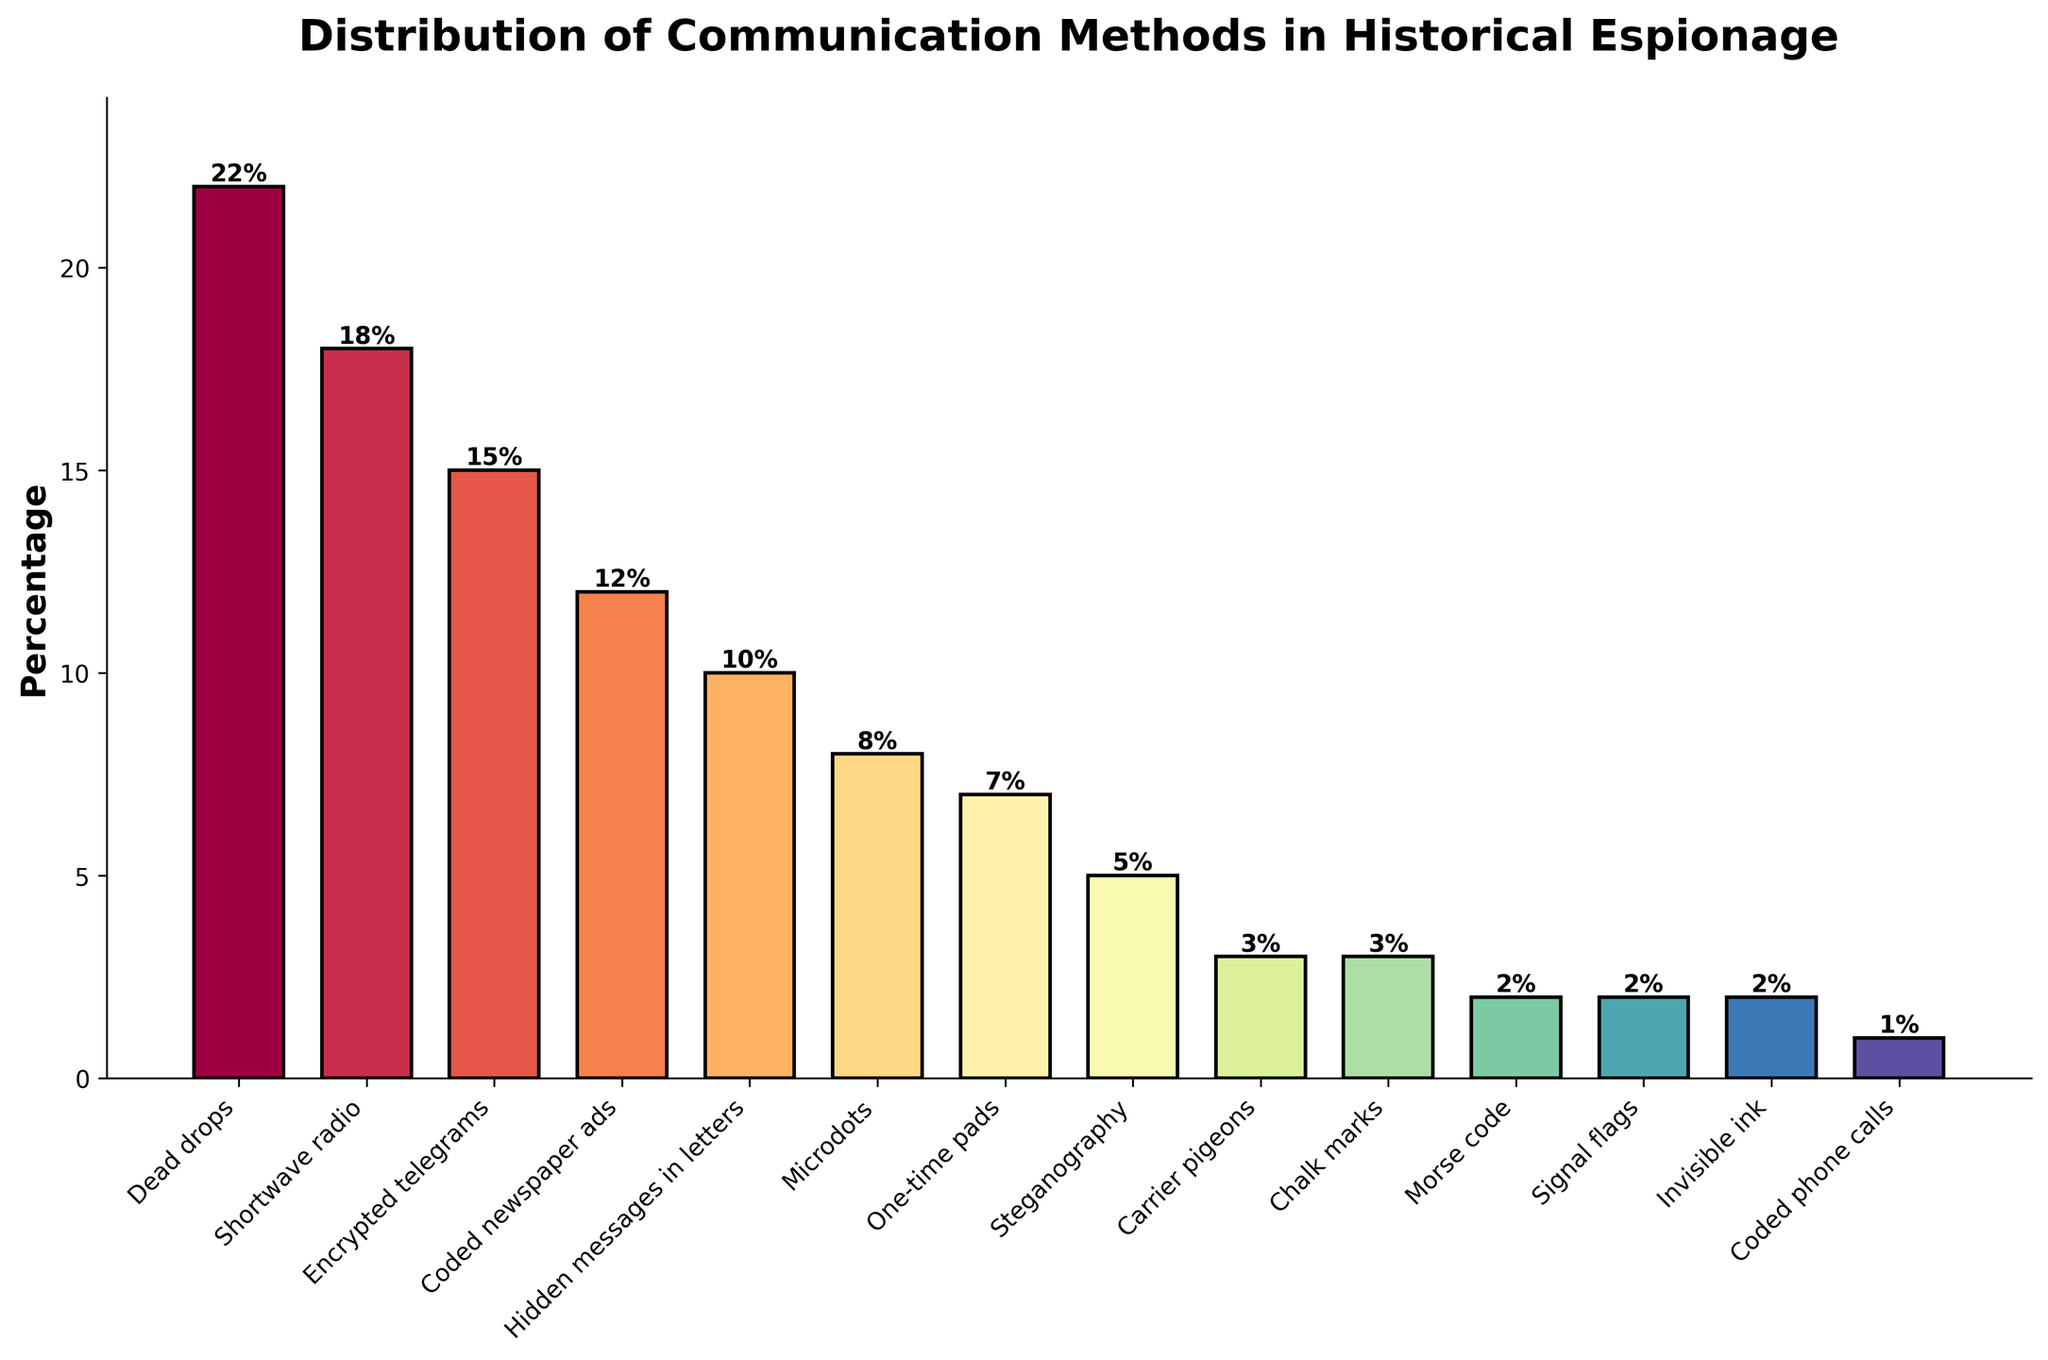What is the method with the highest percentage? The bar chart shows that the method with the highest percentage is at the top of the y-axis, which is "Dead drops" at 22%.
Answer: Dead drops What is the total percentage of methods with a percentage of 10% or higher? Summing the percentages of methods with 10% or higher: Dead drops (22%) + Shortwave radio (18%) + Encrypted telegrams (15%) + Coded newspaper ads (12%) + Hidden messages in letters (10%) = 77%
Answer: 77% Which methods have equal percentages, and what are they? Checking the bar heights for methods with the same percentage, both "Carrier pigeons" and "Chalk marks" have a percentage of 3%, as do "Morse code", "Signal flags", and "Invisible ink" with 2%.
Answer: Carrier pigeons and Chalk marks; Morse code, Signal flags, and Invisible ink What is the difference in percentage between the methods with the highest and the lowest usage? Subtract the percentage of the lowest method (Coded phone calls at 1%) from the highest method (Dead drops at 22%): 22% - 1% = 21%
Answer: 21% How many communication methods are represented in the plot? Count the number of distinct bars (methods) on the x-axis. There are 14 bars representing different methods.
Answer: 14 What is the sum of the percentages for "Microdots" and "One-time pads"? Adding the percentages for "Microdots" (8%) and "One-time pads" (7%): 8% + 7% = 15%
Answer: 15% Which method closely follows "Encrypted telegrams" in terms of percentage? The method immediately after "Encrypted telegrams" (15%) in descending order is "Coded newspaper ads" with 12%.
Answer: Coded newspaper ads What colors are used for the methods with the two lowest percentages? Visual inspection shows that the bars for the two lowest percentages (Morse code, Signal flags, Invisible ink at 2%, and Coded phone calls at 1%) are light colors.
Answer: Light colors Are there any methods that have single-digit percentages but greater than 5%? Checking the single-digit percentage values, those greater than 5% include Microdots (8%) and One-time pads (7%).
Answer: Yes, Microdots and One-time pads 